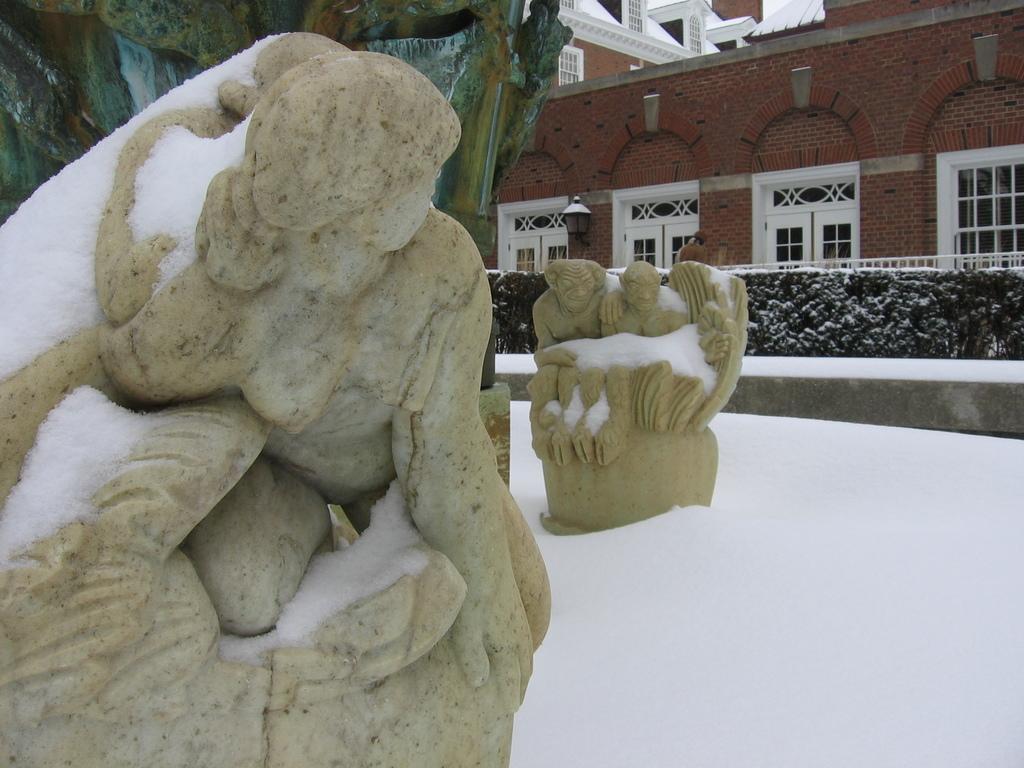In one or two sentences, can you explain what this image depicts? In this image there are sculptors, there is ice on the sculptor's, there is ice towards the bottom of the image, there are plants, there is a building towards the top of the image, there are windows, there is an object towards the top of the image. 